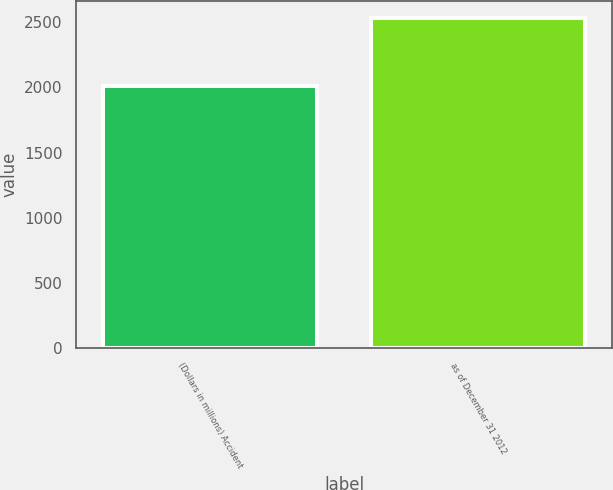<chart> <loc_0><loc_0><loc_500><loc_500><bar_chart><fcel>(Dollars in millions) Accident<fcel>as of December 31 2012<nl><fcel>2012<fcel>2533<nl></chart> 